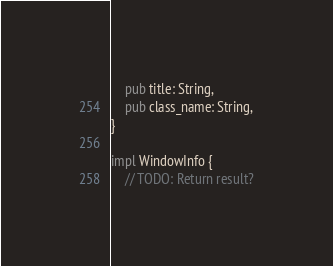<code> <loc_0><loc_0><loc_500><loc_500><_Rust_>    pub title: String,
    pub class_name: String,
}

impl WindowInfo {
    // TODO: Return result?</code> 